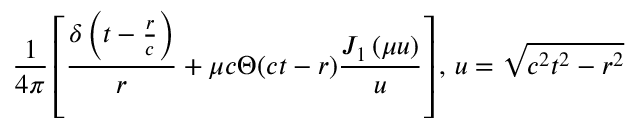Convert formula to latex. <formula><loc_0><loc_0><loc_500><loc_500>{ \frac { 1 } { 4 \pi } } \left [ { \frac { \delta \left ( t - { \frac { r } { c } } \right ) } { r } } + \mu c \Theta ( c t - r ) { \frac { J _ { 1 } \left ( \mu u \right ) } { u } } \right ] , \, u = { \sqrt { c ^ { 2 } t ^ { 2 } - r ^ { 2 } } }</formula> 